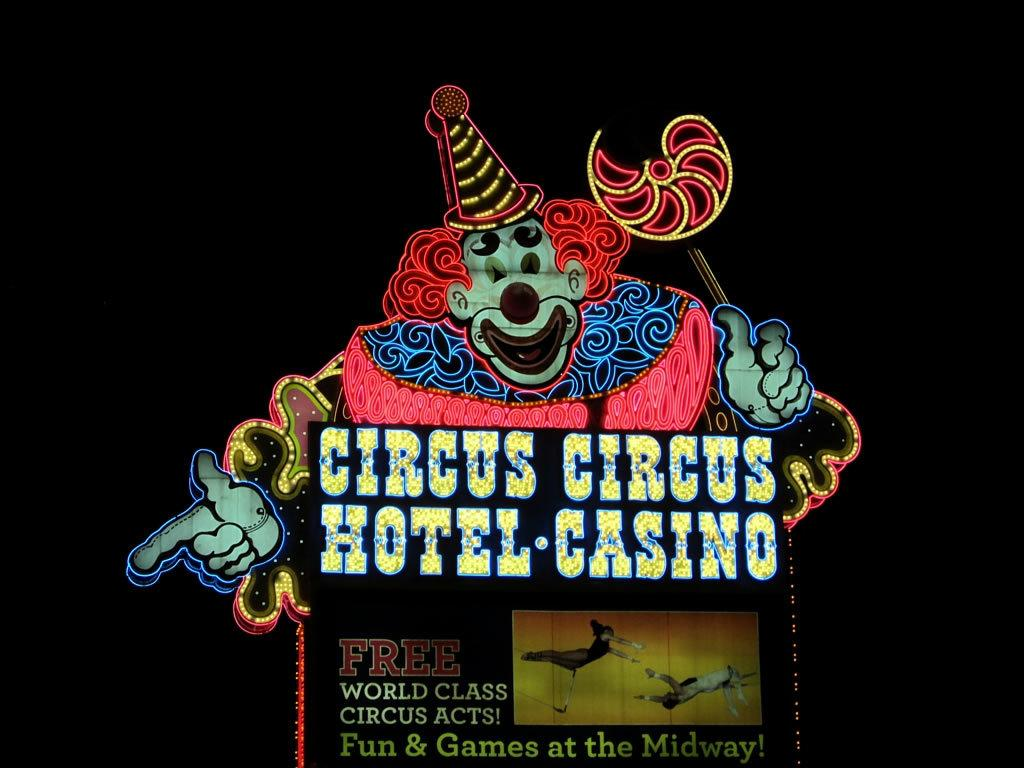<image>
Provide a brief description of the given image. A neon clown on a sign advertising the Circus Circus hotel and Casino. 